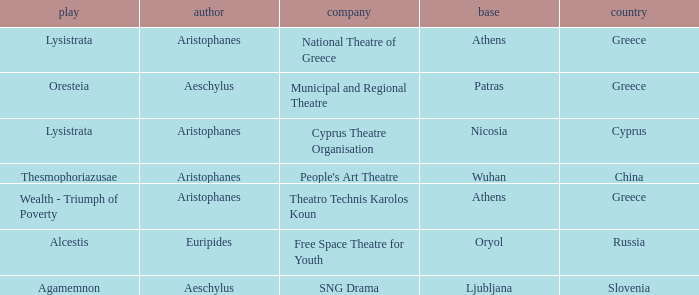What is the play when the company is national theatre of greece? Lysistrata. 